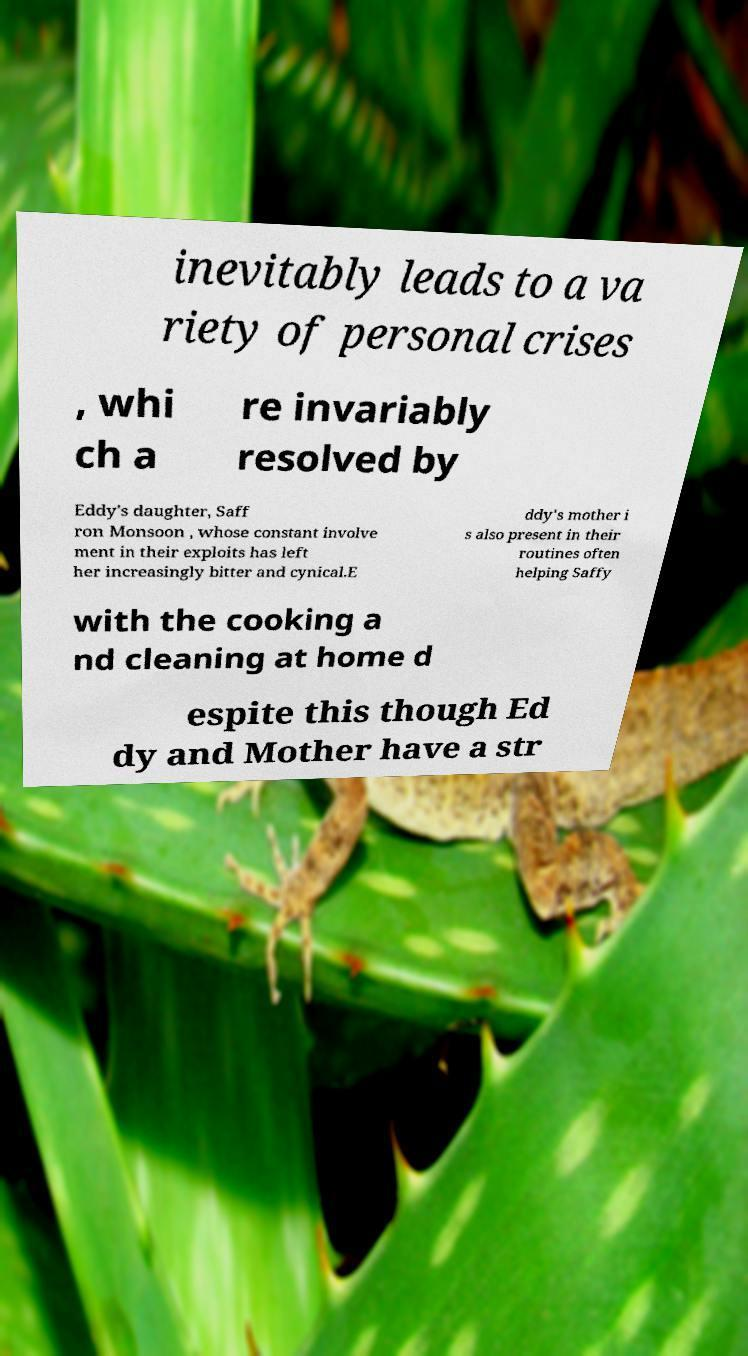Could you extract and type out the text from this image? inevitably leads to a va riety of personal crises , whi ch a re invariably resolved by Eddy's daughter, Saff ron Monsoon , whose constant involve ment in their exploits has left her increasingly bitter and cynical.E ddy's mother i s also present in their routines often helping Saffy with the cooking a nd cleaning at home d espite this though Ed dy and Mother have a str 